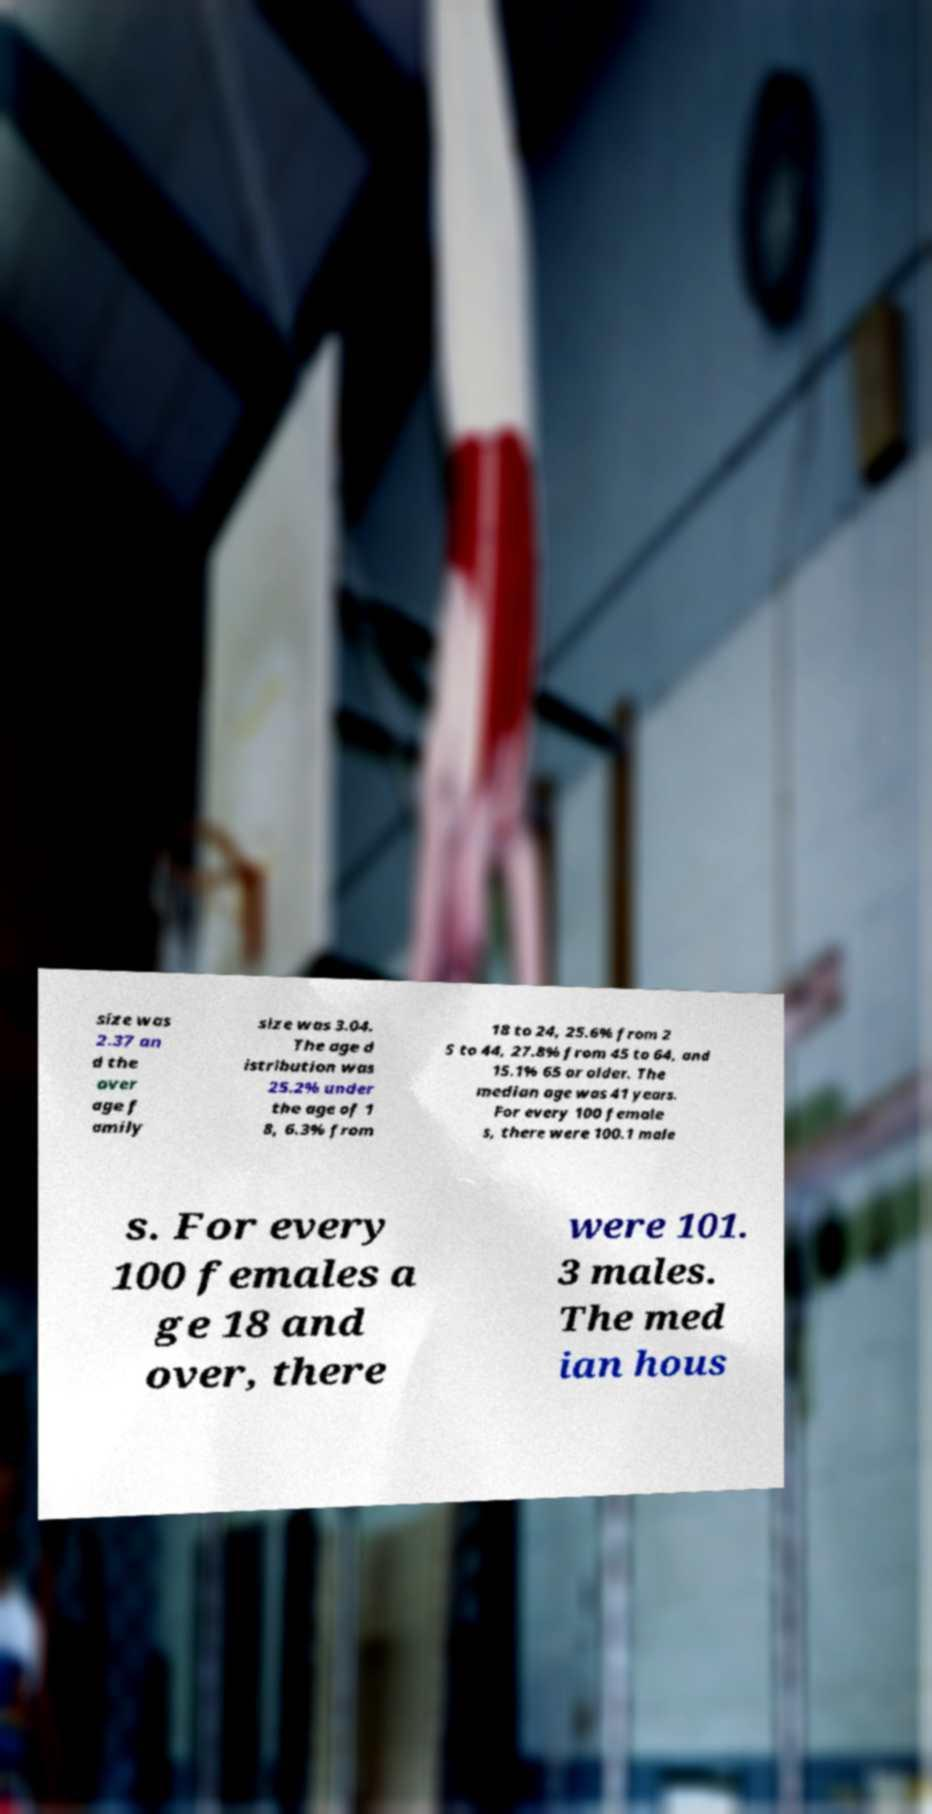Could you extract and type out the text from this image? size was 2.37 an d the aver age f amily size was 3.04. The age d istribution was 25.2% under the age of 1 8, 6.3% from 18 to 24, 25.6% from 2 5 to 44, 27.8% from 45 to 64, and 15.1% 65 or older. The median age was 41 years. For every 100 female s, there were 100.1 male s. For every 100 females a ge 18 and over, there were 101. 3 males. The med ian hous 